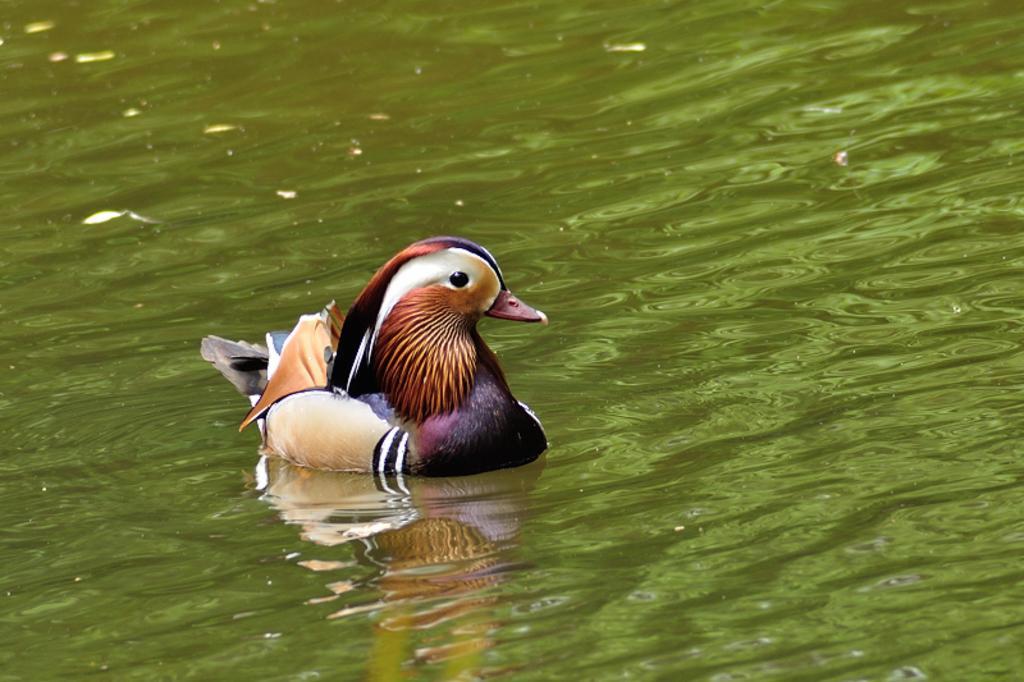Could you give a brief overview of what you see in this image? In this image we can see a bird in the water. 